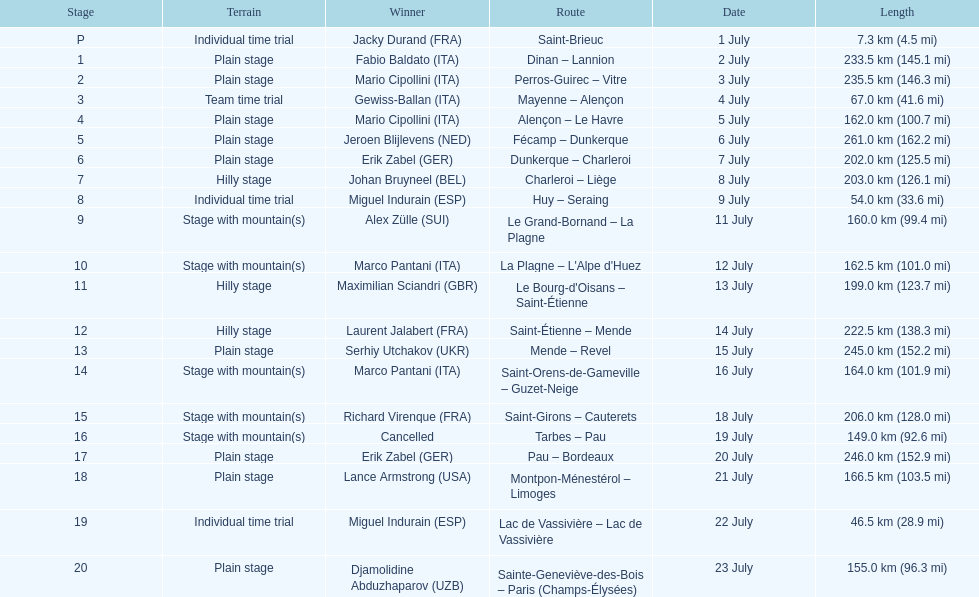Can you parse all the data within this table? {'header': ['Stage', 'Terrain', 'Winner', 'Route', 'Date', 'Length'], 'rows': [['P', 'Individual time trial', 'Jacky Durand\xa0(FRA)', 'Saint-Brieuc', '1 July', '7.3\xa0km (4.5\xa0mi)'], ['1', 'Plain stage', 'Fabio Baldato\xa0(ITA)', 'Dinan – Lannion', '2 July', '233.5\xa0km (145.1\xa0mi)'], ['2', 'Plain stage', 'Mario Cipollini\xa0(ITA)', 'Perros-Guirec – Vitre', '3 July', '235.5\xa0km (146.3\xa0mi)'], ['3', 'Team time trial', 'Gewiss-Ballan\xa0(ITA)', 'Mayenne – Alençon', '4 July', '67.0\xa0km (41.6\xa0mi)'], ['4', 'Plain stage', 'Mario Cipollini\xa0(ITA)', 'Alençon – Le Havre', '5 July', '162.0\xa0km (100.7\xa0mi)'], ['5', 'Plain stage', 'Jeroen Blijlevens\xa0(NED)', 'Fécamp – Dunkerque', '6 July', '261.0\xa0km (162.2\xa0mi)'], ['6', 'Plain stage', 'Erik Zabel\xa0(GER)', 'Dunkerque – Charleroi', '7 July', '202.0\xa0km (125.5\xa0mi)'], ['7', 'Hilly stage', 'Johan Bruyneel\xa0(BEL)', 'Charleroi – Liège', '8 July', '203.0\xa0km (126.1\xa0mi)'], ['8', 'Individual time trial', 'Miguel Indurain\xa0(ESP)', 'Huy – Seraing', '9 July', '54.0\xa0km (33.6\xa0mi)'], ['9', 'Stage with mountain(s)', 'Alex Zülle\xa0(SUI)', 'Le Grand-Bornand – La Plagne', '11 July', '160.0\xa0km (99.4\xa0mi)'], ['10', 'Stage with mountain(s)', 'Marco Pantani\xa0(ITA)', "La Plagne – L'Alpe d'Huez", '12 July', '162.5\xa0km (101.0\xa0mi)'], ['11', 'Hilly stage', 'Maximilian Sciandri\xa0(GBR)', "Le Bourg-d'Oisans – Saint-Étienne", '13 July', '199.0\xa0km (123.7\xa0mi)'], ['12', 'Hilly stage', 'Laurent Jalabert\xa0(FRA)', 'Saint-Étienne – Mende', '14 July', '222.5\xa0km (138.3\xa0mi)'], ['13', 'Plain stage', 'Serhiy Utchakov\xa0(UKR)', 'Mende – Revel', '15 July', '245.0\xa0km (152.2\xa0mi)'], ['14', 'Stage with mountain(s)', 'Marco Pantani\xa0(ITA)', 'Saint-Orens-de-Gameville – Guzet-Neige', '16 July', '164.0\xa0km (101.9\xa0mi)'], ['15', 'Stage with mountain(s)', 'Richard Virenque\xa0(FRA)', 'Saint-Girons – Cauterets', '18 July', '206.0\xa0km (128.0\xa0mi)'], ['16', 'Stage with mountain(s)', 'Cancelled', 'Tarbes – Pau', '19 July', '149.0\xa0km (92.6\xa0mi)'], ['17', 'Plain stage', 'Erik Zabel\xa0(GER)', 'Pau – Bordeaux', '20 July', '246.0\xa0km (152.9\xa0mi)'], ['18', 'Plain stage', 'Lance Armstrong\xa0(USA)', 'Montpon-Ménestérol – Limoges', '21 July', '166.5\xa0km (103.5\xa0mi)'], ['19', 'Individual time trial', 'Miguel Indurain\xa0(ESP)', 'Lac de Vassivière – Lac de Vassivière', '22 July', '46.5\xa0km (28.9\xa0mi)'], ['20', 'Plain stage', 'Djamolidine Abduzhaparov\xa0(UZB)', 'Sainte-Geneviève-des-Bois – Paris (Champs-Élysées)', '23 July', '155.0\xa0km (96.3\xa0mi)']]} How many consecutive km were raced on july 8th? 203.0 km (126.1 mi). 